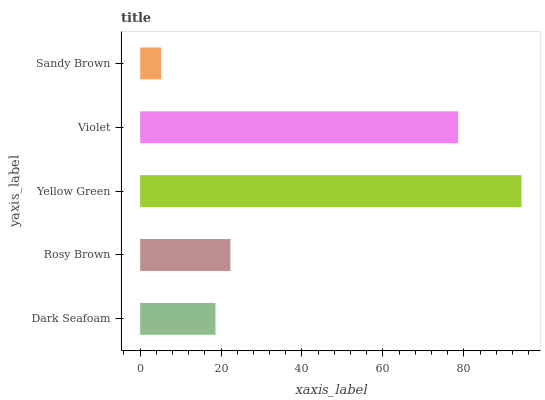Is Sandy Brown the minimum?
Answer yes or no. Yes. Is Yellow Green the maximum?
Answer yes or no. Yes. Is Rosy Brown the minimum?
Answer yes or no. No. Is Rosy Brown the maximum?
Answer yes or no. No. Is Rosy Brown greater than Dark Seafoam?
Answer yes or no. Yes. Is Dark Seafoam less than Rosy Brown?
Answer yes or no. Yes. Is Dark Seafoam greater than Rosy Brown?
Answer yes or no. No. Is Rosy Brown less than Dark Seafoam?
Answer yes or no. No. Is Rosy Brown the high median?
Answer yes or no. Yes. Is Rosy Brown the low median?
Answer yes or no. Yes. Is Dark Seafoam the high median?
Answer yes or no. No. Is Violet the low median?
Answer yes or no. No. 